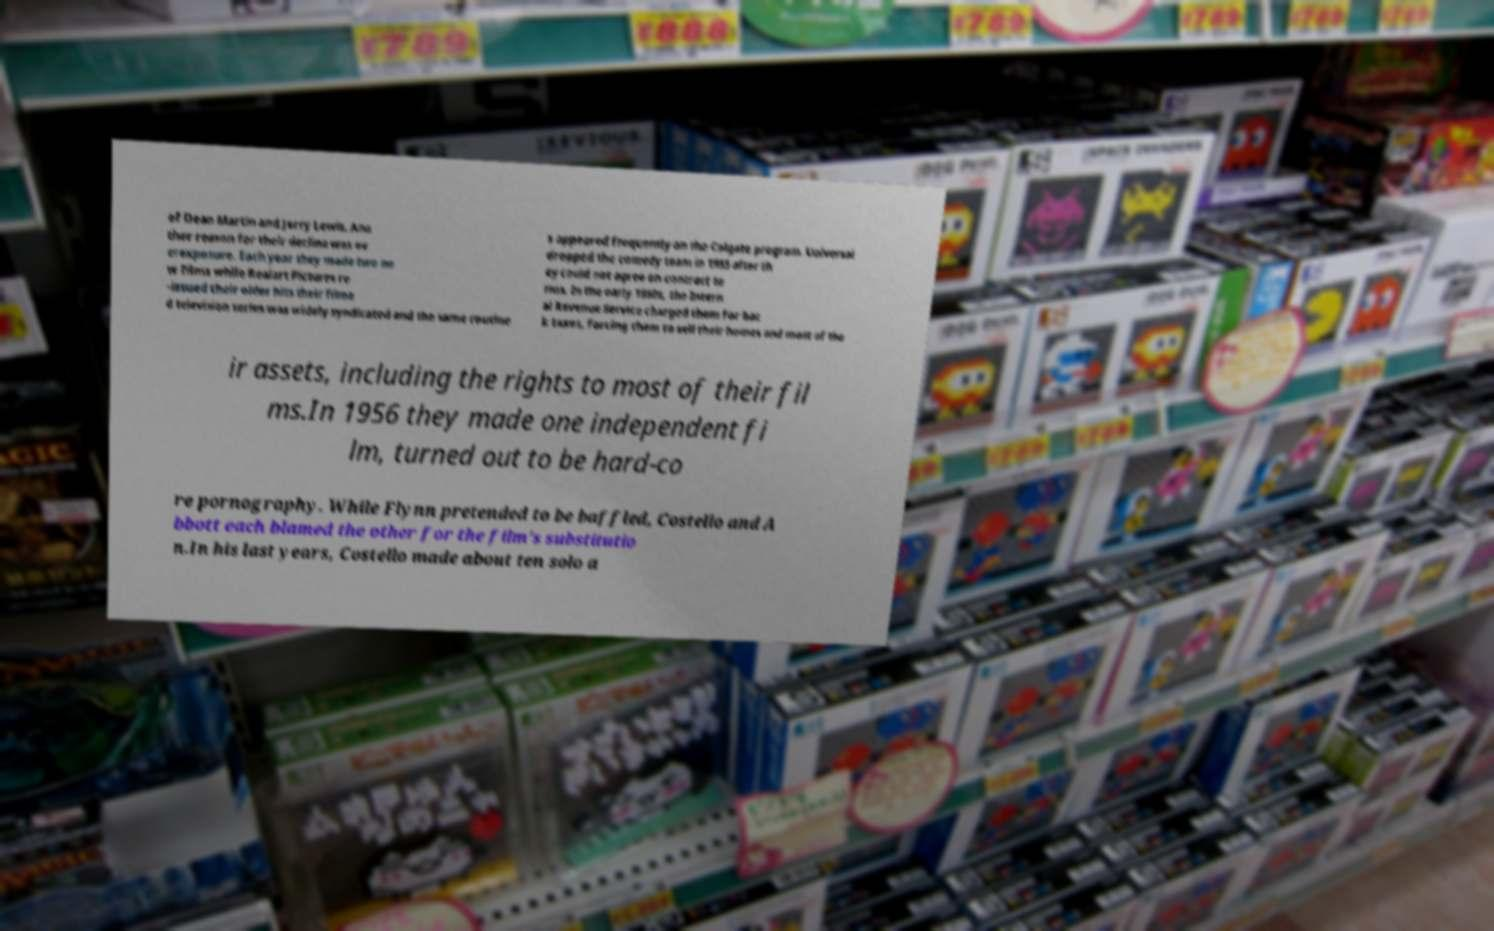Could you extract and type out the text from this image? of Dean Martin and Jerry Lewis. Ano ther reason for their decline was ov erexposure. Each year they made two ne w films while Realart Pictures re -issued their older hits their filme d television series was widely syndicated and the same routine s appeared frequently on the Colgate program. Universal dropped the comedy team in 1955 after th ey could not agree on contract te rms. In the early 1950s, the Intern al Revenue Service charged them for bac k taxes, forcing them to sell their homes and most of the ir assets, including the rights to most of their fil ms.In 1956 they made one independent fi lm, turned out to be hard-co re pornography. While Flynn pretended to be baffled, Costello and A bbott each blamed the other for the film's substitutio n.In his last years, Costello made about ten solo a 